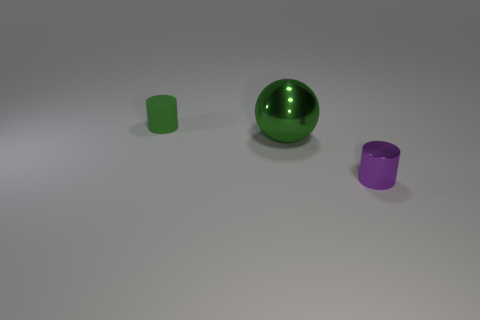Add 1 gray metal objects. How many objects exist? 4 Subtract all purple cylinders. Subtract all cyan blocks. How many cylinders are left? 1 Subtract all balls. How many objects are left? 2 Subtract 0 cyan cylinders. How many objects are left? 3 Subtract all large blue metal cylinders. Subtract all large spheres. How many objects are left? 2 Add 3 purple cylinders. How many purple cylinders are left? 4 Add 2 green shiny objects. How many green shiny objects exist? 3 